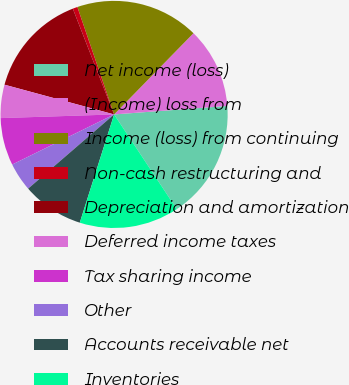<chart> <loc_0><loc_0><loc_500><loc_500><pie_chart><fcel>Net income (loss)<fcel>(Income) loss from<fcel>Income (loss) from continuing<fcel>Non-cash restructuring and<fcel>Depreciation and amortization<fcel>Deferred income taxes<fcel>Tax sharing income<fcel>Other<fcel>Accounts receivable net<fcel>Inventories<nl><fcel>16.89%<fcel>11.49%<fcel>17.56%<fcel>0.68%<fcel>14.86%<fcel>4.73%<fcel>6.76%<fcel>4.06%<fcel>8.78%<fcel>14.19%<nl></chart> 